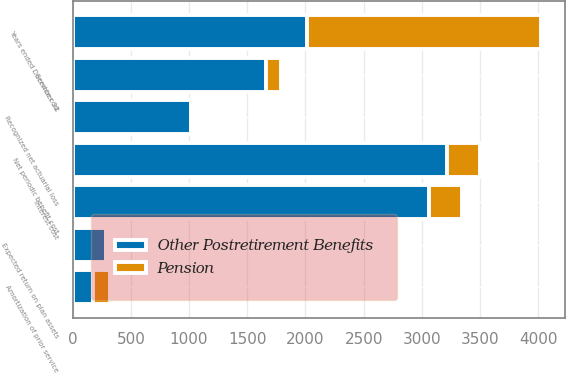Convert chart to OTSL. <chart><loc_0><loc_0><loc_500><loc_500><stacked_bar_chart><ecel><fcel>Years ended December 31<fcel>Service cost<fcel>Interest cost<fcel>Expected return on plan assets<fcel>Amortization of prior service<fcel>Recognized net actuarial loss<fcel>Net periodic benefit cost<nl><fcel>Other Postretirement Benefits<fcel>2014<fcel>1661<fcel>3058<fcel>289<fcel>177<fcel>1020<fcel>3215<nl><fcel>Pension<fcel>2014<fcel>129<fcel>289<fcel>8<fcel>144<fcel>8<fcel>287<nl></chart> 